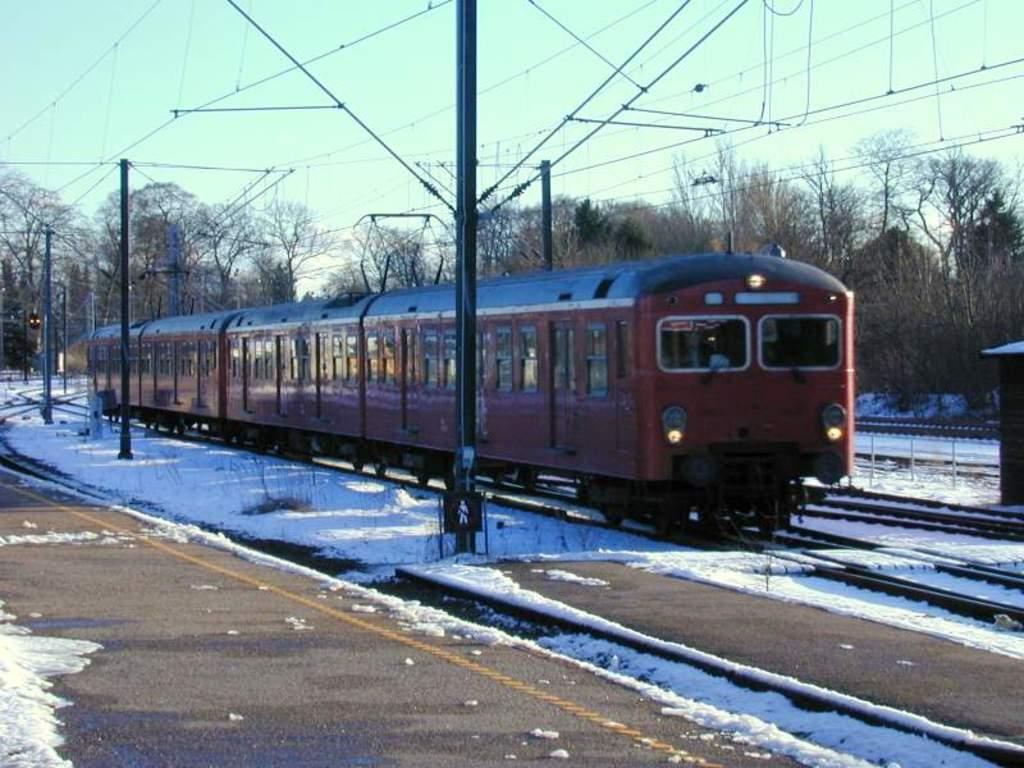What is the main subject of the image? The main subject of the image is a train on the track. What can be seen in the image besides the train? There are poles, trees, and sky visible in the background of the image. There are also wires at the top of the image. What is the weather condition in the image? Snow is present in the image, indicating a snowy condition. What type of shoes can be seen on the train in the image? There are no shoes visible on the train in the image. Can you describe the frog's habitat in the image? There is no frog present in the image. 